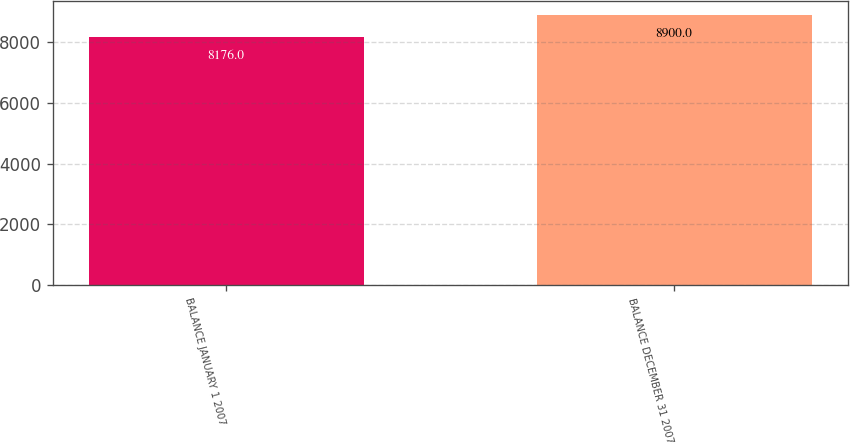Convert chart to OTSL. <chart><loc_0><loc_0><loc_500><loc_500><bar_chart><fcel>BALANCE JANUARY 1 2007<fcel>BALANCE DECEMBER 31 2007<nl><fcel>8176<fcel>8900<nl></chart> 